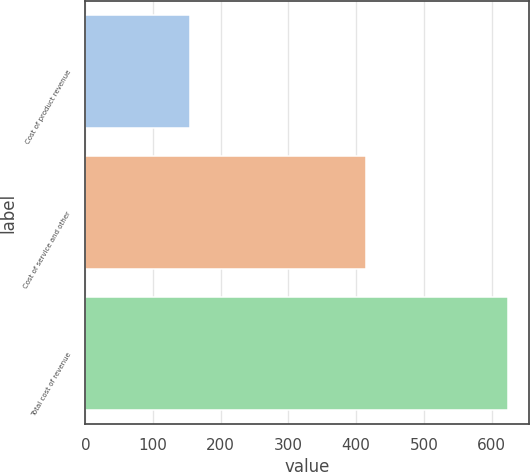<chart> <loc_0><loc_0><loc_500><loc_500><bar_chart><fcel>Cost of product revenue<fcel>Cost of service and other<fcel>Total cost of revenue<nl><fcel>154.1<fcel>414.1<fcel>624.2<nl></chart> 